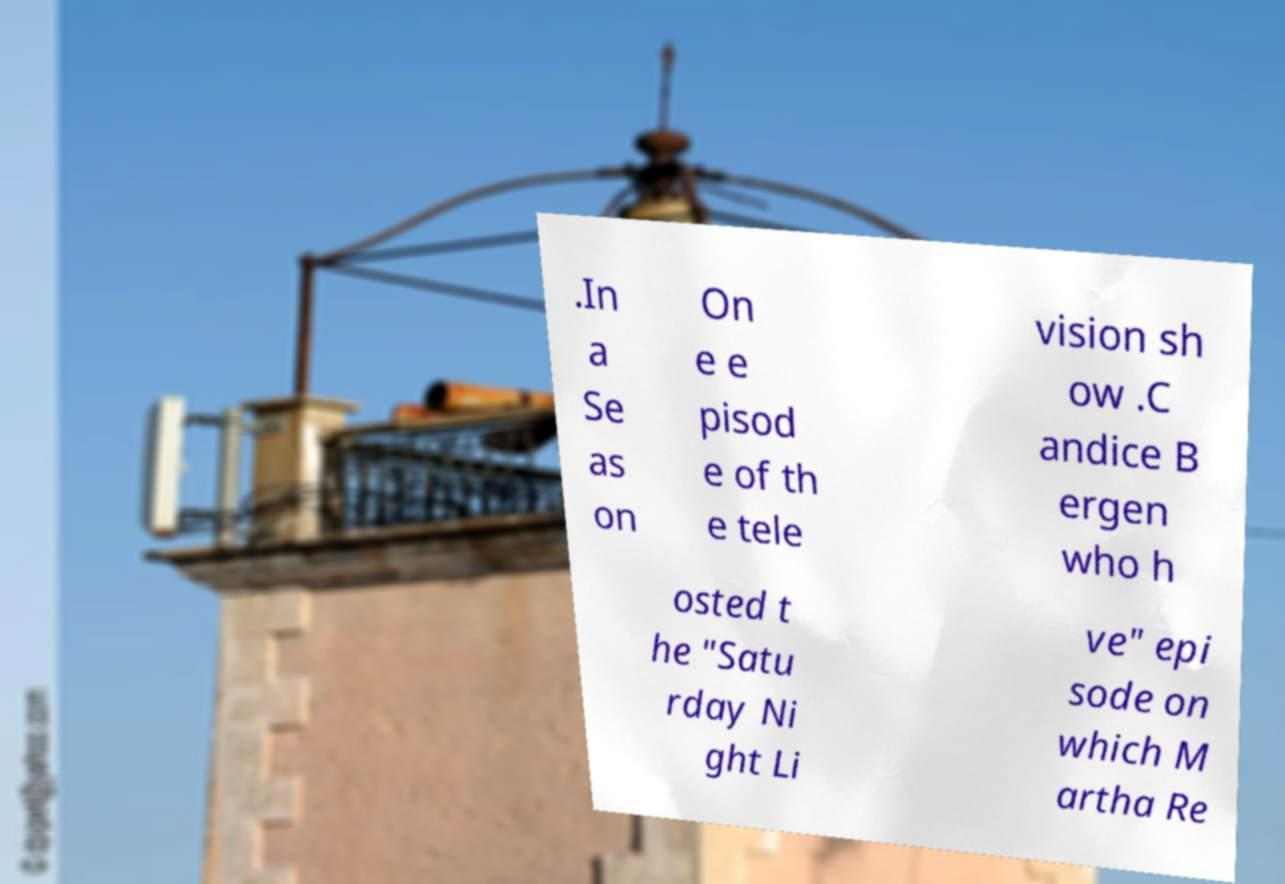Please identify and transcribe the text found in this image. .In a Se as on On e e pisod e of th e tele vision sh ow .C andice B ergen who h osted t he "Satu rday Ni ght Li ve" epi sode on which M artha Re 